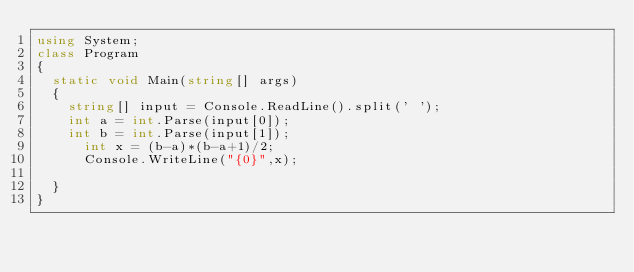<code> <loc_0><loc_0><loc_500><loc_500><_C#_>using System;
class Program
{
	static void Main(string[] args)
	{
		string[] input = Console.ReadLine().split(' ');
		int a = int.Parse(input[0]);
		int b = int.Parse(input[1]);
	    int x = (b-a)*(b-a+1)/2;
	    Console.WriteLine("{0}",x);
		
	}
}</code> 